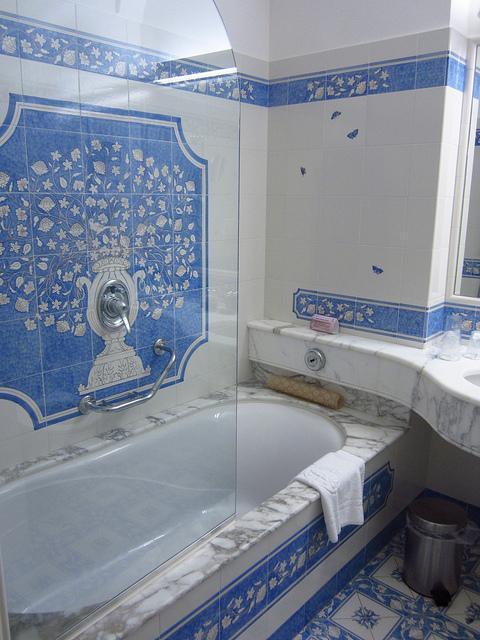How many dominos pizza logos do you see?
Give a very brief answer. 0. 